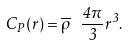Convert formula to latex. <formula><loc_0><loc_0><loc_500><loc_500>C _ { P } ( r ) = \overline { \rho } \ \frac { 4 \pi } { 3 } r ^ { 3 } .</formula> 